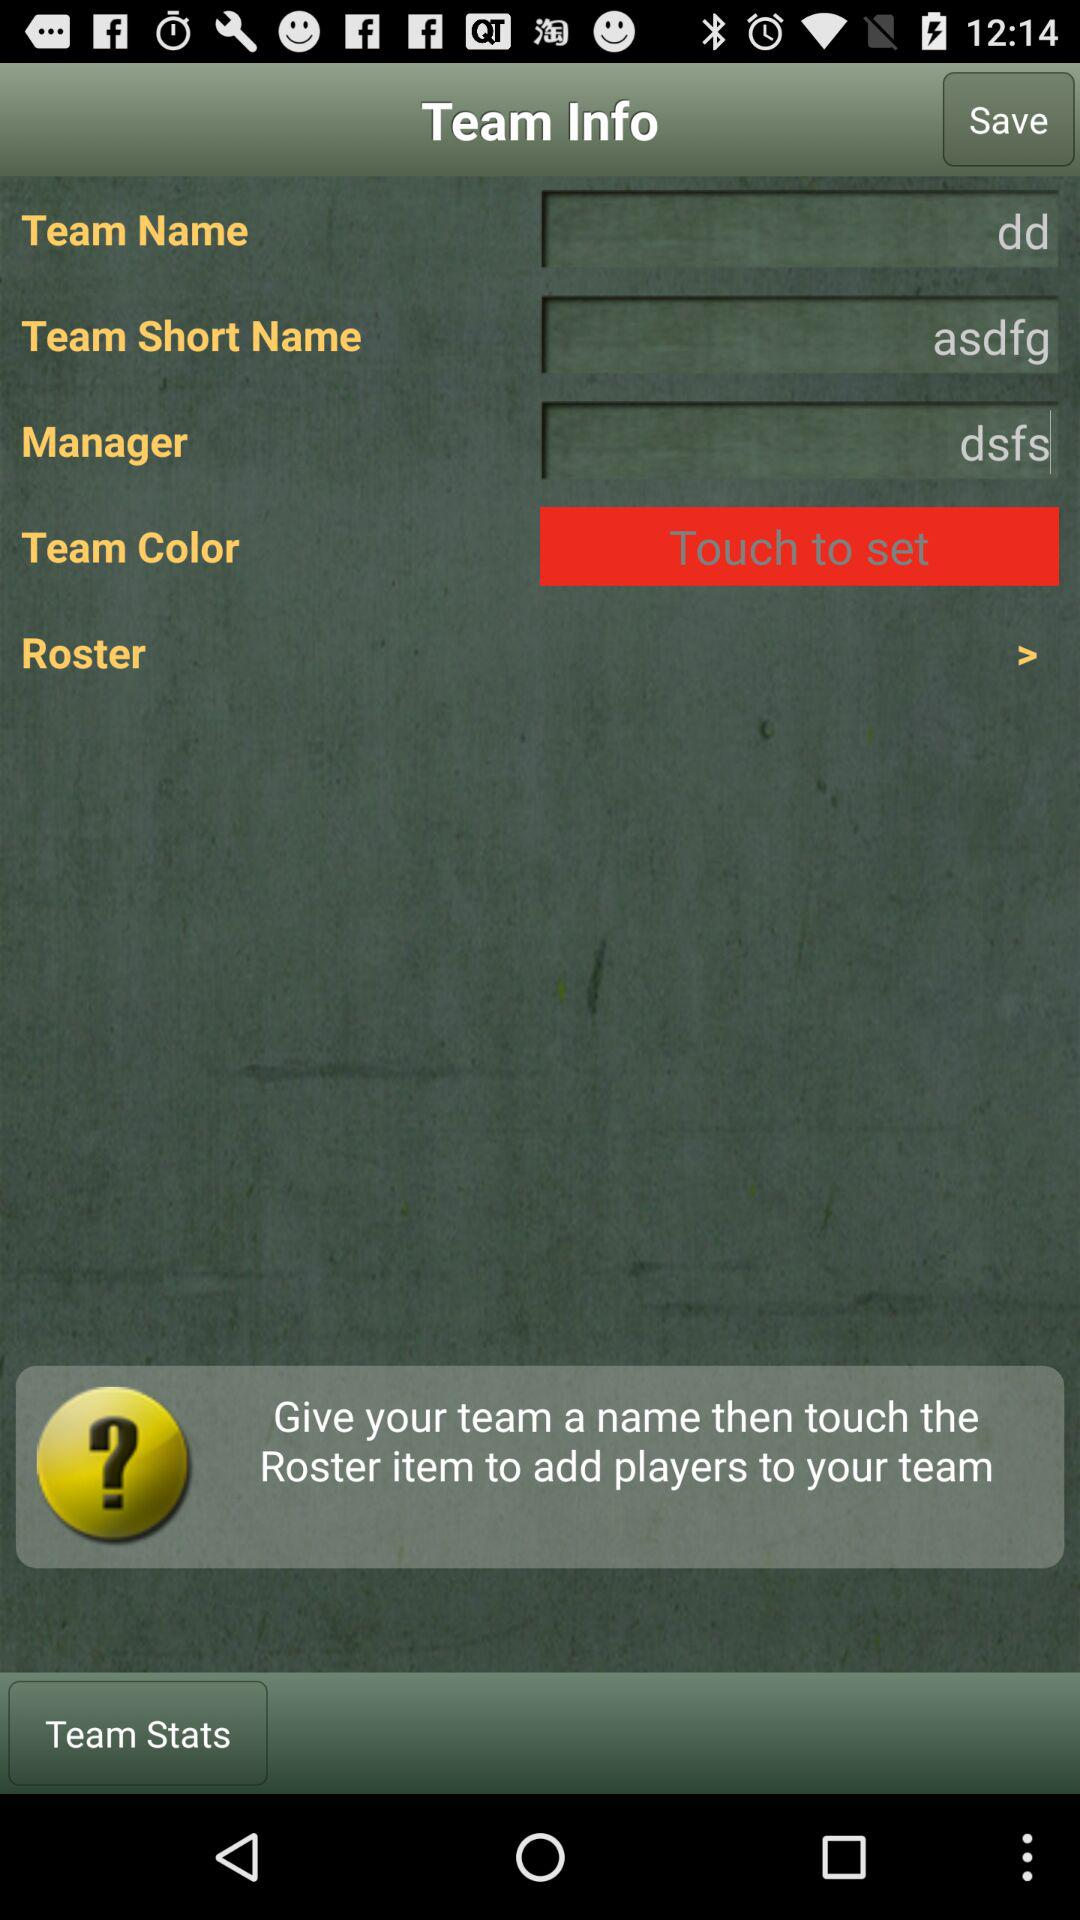What is the team name? The team name is "dd". 